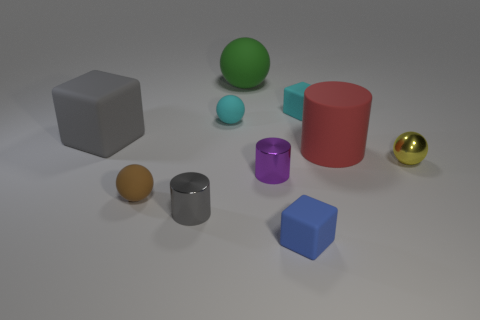Do the brown sphere that is to the right of the gray rubber cube and the large green rubber object have the same size?
Give a very brief answer. No. What size is the cube that is both behind the red rubber object and on the left side of the cyan block?
Give a very brief answer. Large. There is a tiny thing that is the same color as the big block; what material is it?
Make the answer very short. Metal. How many things have the same color as the large block?
Your response must be concise. 1. Is the number of objects to the right of the small cyan matte cube the same as the number of big green things?
Provide a succinct answer. No. The tiny shiny sphere has what color?
Your answer should be compact. Yellow. There is a gray thing that is the same material as the tiny yellow ball; what size is it?
Offer a terse response. Small. There is a big ball that is the same material as the tiny cyan ball; what is its color?
Provide a short and direct response. Green. Is there a yellow matte object that has the same size as the blue matte block?
Offer a terse response. No. What material is the big thing that is the same shape as the small gray object?
Offer a terse response. Rubber. 